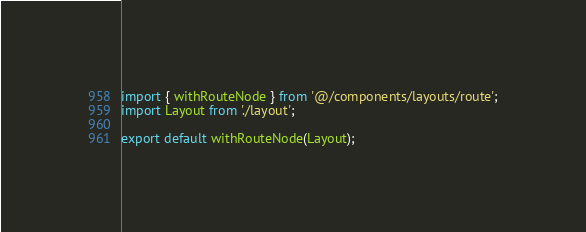Convert code to text. <code><loc_0><loc_0><loc_500><loc_500><_TypeScript_>import { withRouteNode } from '@/components/layouts/route';
import Layout from './layout';

export default withRouteNode(Layout);
</code> 